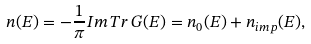<formula> <loc_0><loc_0><loc_500><loc_500>n ( E ) = - \frac { 1 } { \pi } { I m } \, T r \, G ( E ) = n _ { 0 } ( E ) + n _ { i m p } ( E ) ,</formula> 